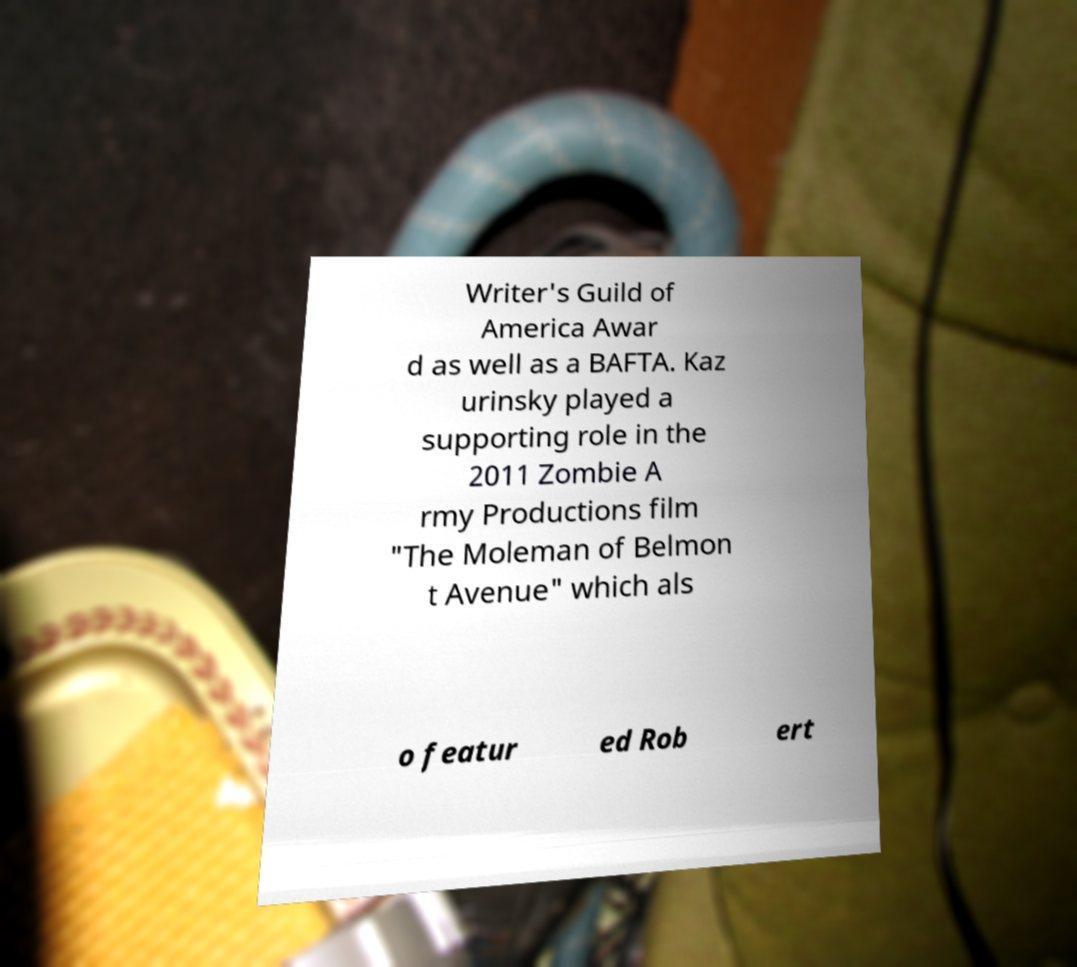Please identify and transcribe the text found in this image. Writer's Guild of America Awar d as well as a BAFTA. Kaz urinsky played a supporting role in the 2011 Zombie A rmy Productions film "The Moleman of Belmon t Avenue" which als o featur ed Rob ert 